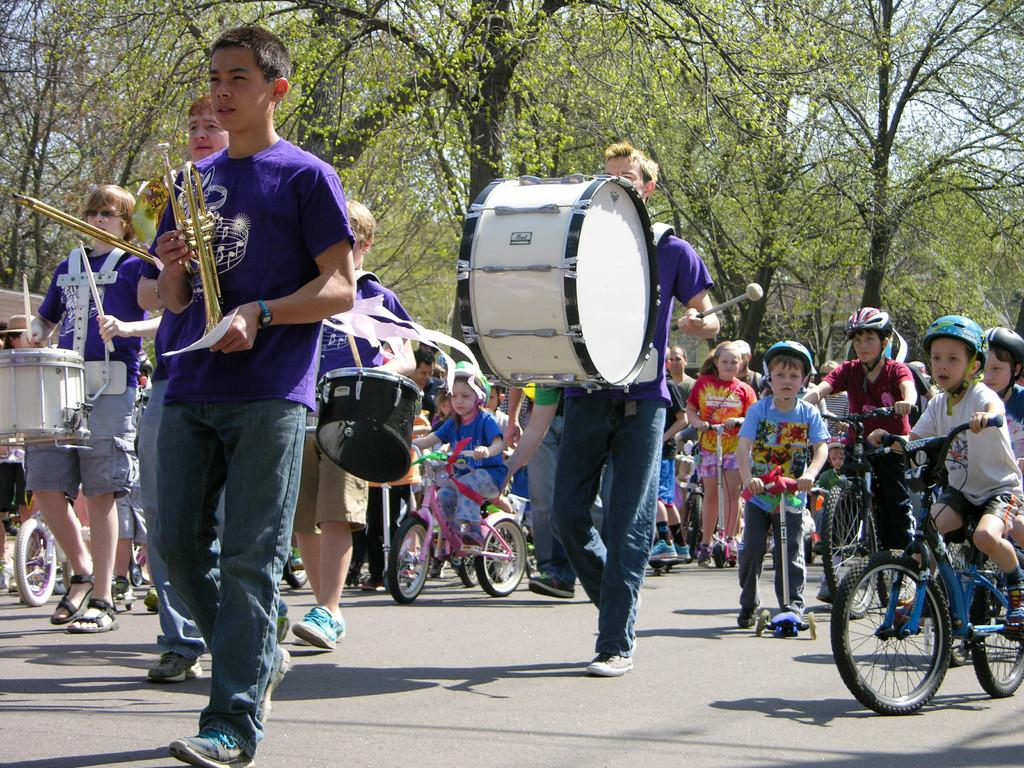What can be seen in the image? There are children in the image. What are the children doing? The children are walking and riding bicycles. Are any of the children holding anything? Yes, some children are holding musical instruments. What can be seen in the background of the image? There are trees around in the image, and the sky is visible above. Can you see a rake being used by any of the children in the image? No, there is no rake present in the image. What type of turkey can be seen in the image? There is no turkey present in the image. 